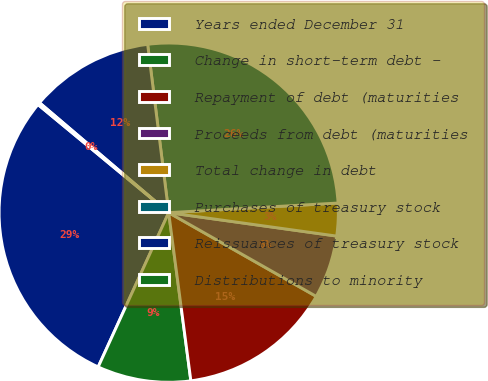<chart> <loc_0><loc_0><loc_500><loc_500><pie_chart><fcel>Years ended December 31<fcel>Change in short-term debt -<fcel>Repayment of debt (maturities<fcel>Proceeds from debt (maturities<fcel>Total change in debt<fcel>Purchases of treasury stock<fcel>Reissuances of treasury stock<fcel>Distributions to minority<nl><fcel>29.18%<fcel>8.91%<fcel>14.7%<fcel>6.01%<fcel>3.11%<fcel>26.08%<fcel>11.8%<fcel>0.22%<nl></chart> 